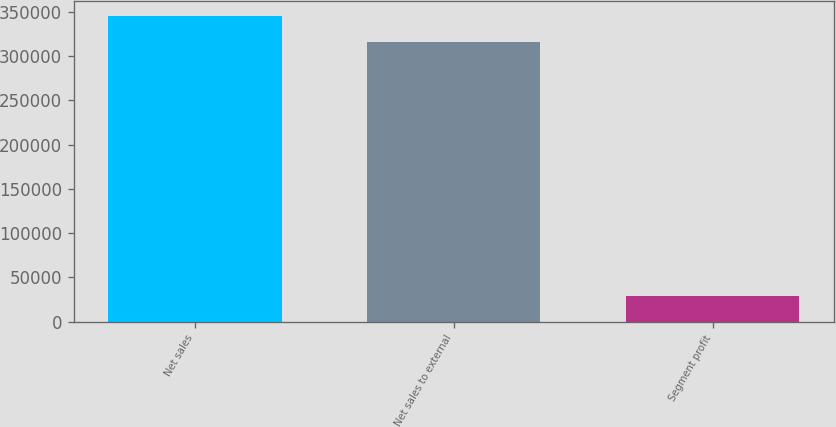Convert chart. <chart><loc_0><loc_0><loc_500><loc_500><bar_chart><fcel>Net sales<fcel>Net sales to external<fcel>Segment profit<nl><fcel>345482<fcel>316203<fcel>28691<nl></chart> 